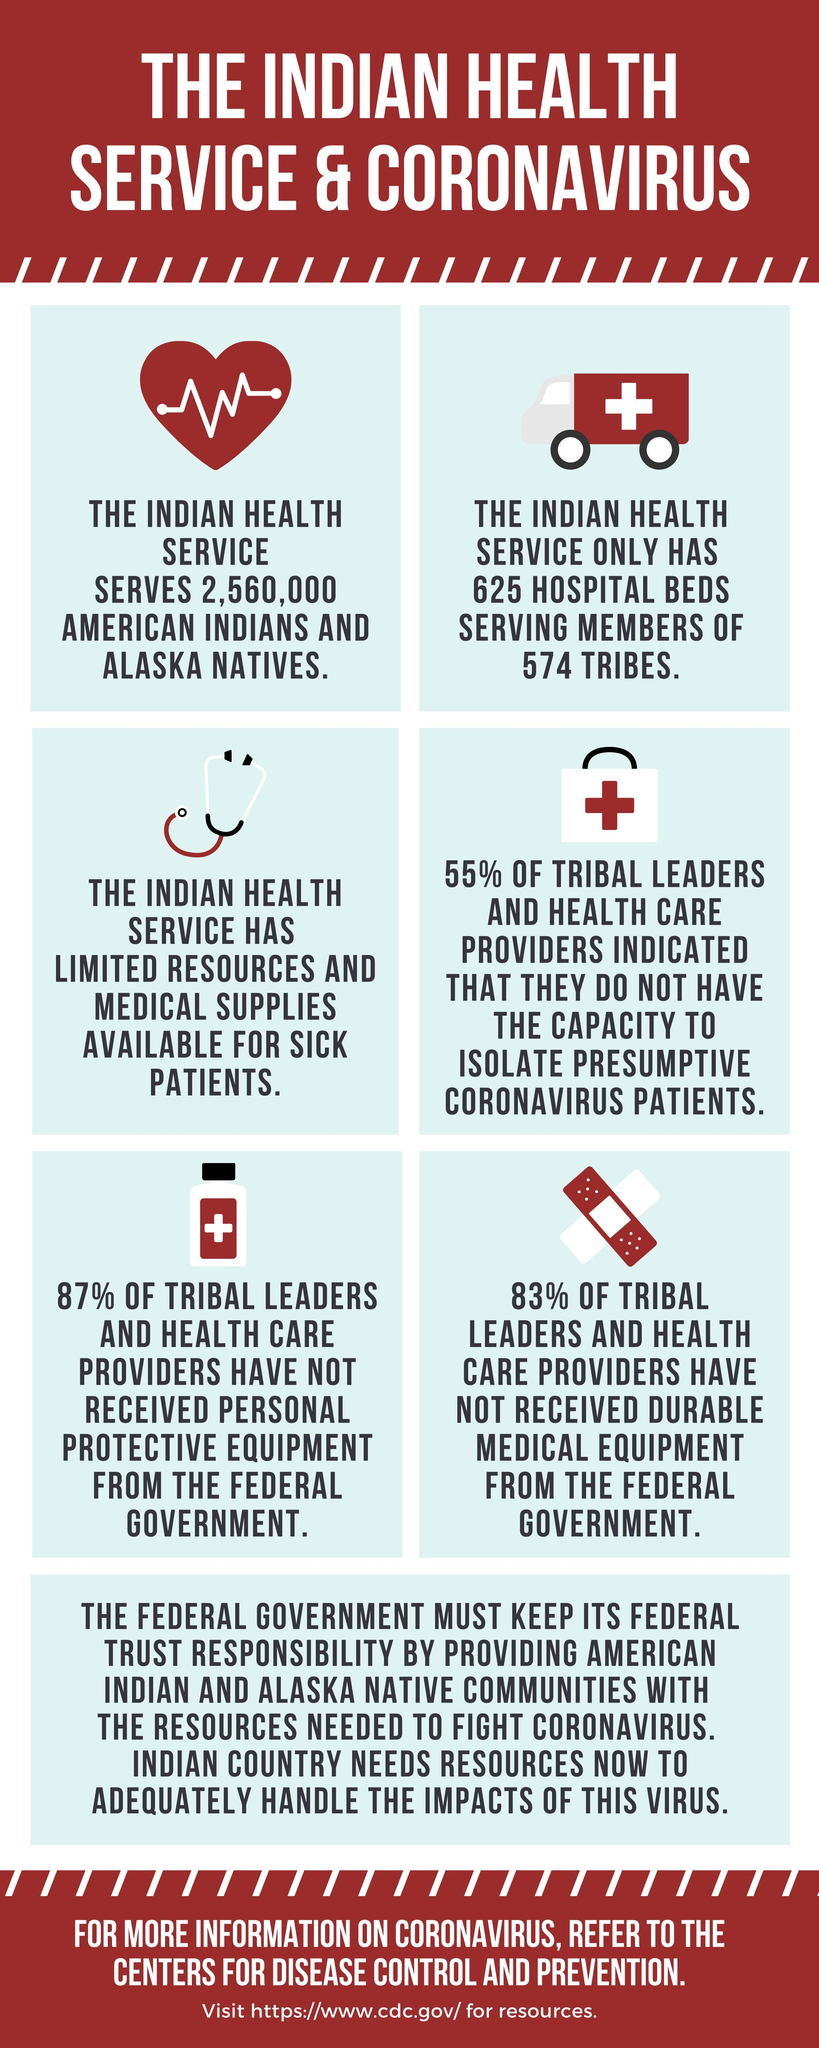Who indicated about lack of isolation facilities for coronavirus patients?
Answer the question with a short phrase. tribal leaders and health care providers Who have not received personal protective equipment from federal government? 87% of tribal leaders and health care providers Members of how many tribes are served by Indian health service? 574 Who haven't received durable medical equipment from federal government? 83% of tribal leaders and health care providers What has 87% of tribal leaders not received from federal government? personal protective equipment Who has limited resources and medical supplies for sick patients? the Indian health service How many beds does the Indian Health service have? 625 hospital beds what percent of the leaders indicated about lack of isolation facilities? 55% Which people does the Indian health service serve? American Indians and Alaska Natives how many people are served by the Indian health service? 2,560,000 